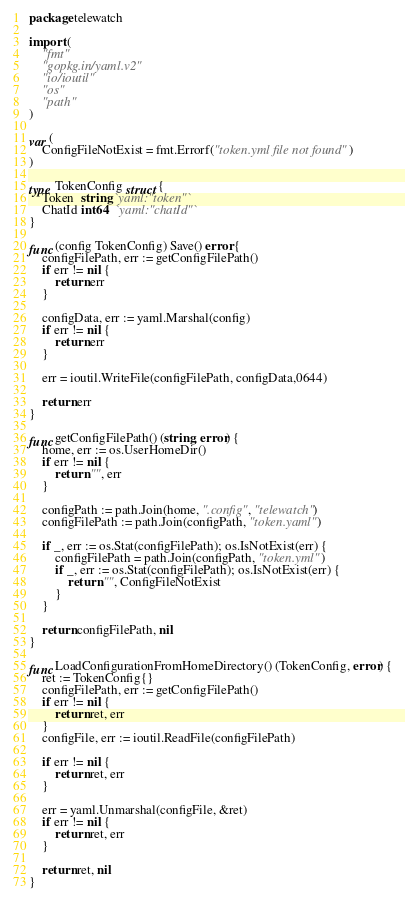<code> <loc_0><loc_0><loc_500><loc_500><_Go_>package telewatch

import (
	"fmt"
	"gopkg.in/yaml.v2"
	"io/ioutil"
	"os"
	"path"
)

var (
	ConfigFileNotExist = fmt.Errorf("token.yml file not found")
)

type TokenConfig struct {
	Token  string `yaml:"token"`
	ChatId int64  `yaml:"chatId"`
}

func (config TokenConfig) Save() error {
	configFilePath, err := getConfigFilePath()
	if err != nil {
		return err
	}

	configData, err := yaml.Marshal(config)
	if err != nil {
		return err
	}

	err = ioutil.WriteFile(configFilePath, configData,0644)

	return err
}

func getConfigFilePath() (string, error) {
	home, err := os.UserHomeDir()
	if err != nil {
		return "", err
	}

	configPath := path.Join(home, ".config", "telewatch")
	configFilePath := path.Join(configPath, "token.yaml")

	if _, err := os.Stat(configFilePath); os.IsNotExist(err) {
		configFilePath = path.Join(configPath, "token.yml")
		if _, err := os.Stat(configFilePath); os.IsNotExist(err) {
			return "", ConfigFileNotExist
		}
	}

	return configFilePath, nil
}

func LoadConfigurationFromHomeDirectory() (TokenConfig, error) {
	ret := TokenConfig{}
	configFilePath, err := getConfigFilePath()
	if err != nil {
		return ret, err
	}
	configFile, err := ioutil.ReadFile(configFilePath)

	if err != nil {
		return ret, err
	}

	err = yaml.Unmarshal(configFile, &ret)
	if err != nil {
		return ret, err
	}

	return ret, nil
}
</code> 